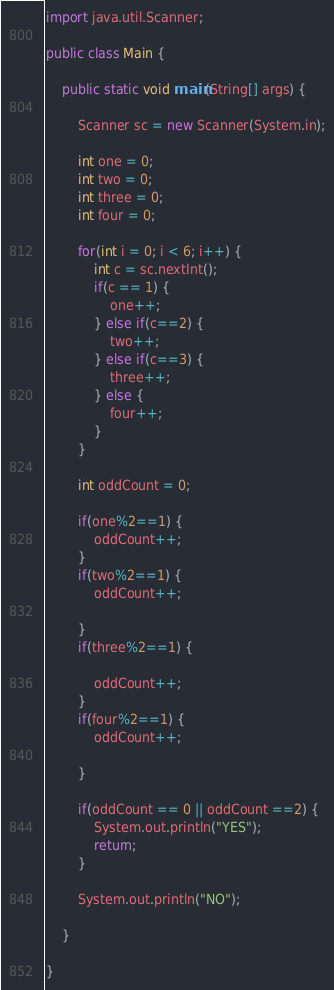Convert code to text. <code><loc_0><loc_0><loc_500><loc_500><_Java_>import java.util.Scanner;

public class Main {

	public static void main(String[] args) {

		Scanner sc = new Scanner(System.in);

		int one = 0;
		int two = 0;
		int three = 0;
		int four = 0;

		for(int i = 0; i < 6; i++) {
			int c = sc.nextInt();
			if(c == 1) {
				one++;
			} else if(c==2) {
				two++;
			} else if(c==3) {
				three++;
			} else {
				four++;
			}
		}

		int oddCount = 0;

		if(one%2==1) {
			oddCount++;
		}
		if(two%2==1) {
			oddCount++;

		}
		if(three%2==1) {

			oddCount++;
		}
		if(four%2==1) {
			oddCount++;

		}

		if(oddCount == 0 || oddCount ==2) {
			System.out.println("YES");
			return;
		}

		System.out.println("NO");

	}

}
</code> 